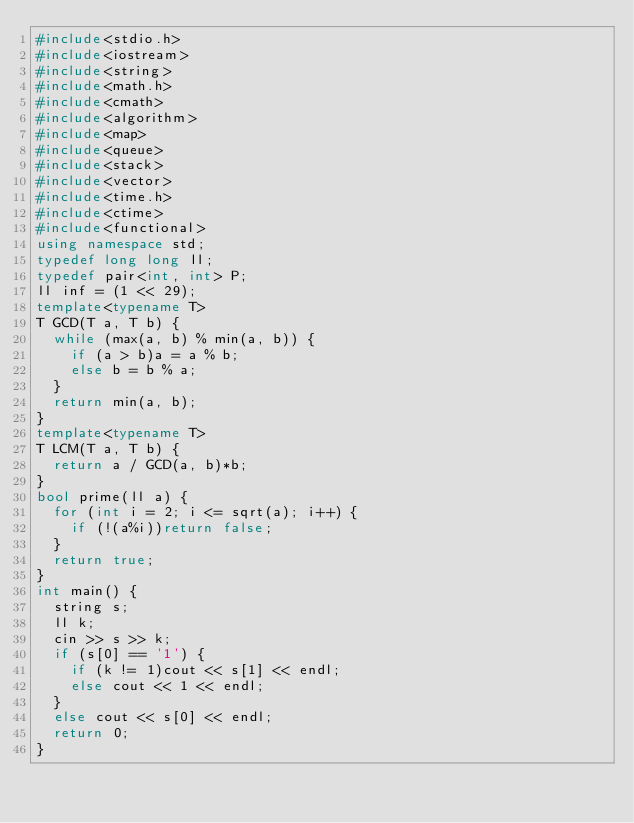<code> <loc_0><loc_0><loc_500><loc_500><_C++_>#include<stdio.h>
#include<iostream>
#include<string>
#include<math.h>
#include<cmath>
#include<algorithm>
#include<map>
#include<queue>
#include<stack>
#include<vector>
#include<time.h>
#include<ctime>
#include<functional>
using namespace std;
typedef long long ll;
typedef pair<int, int> P;
ll inf = (1 << 29);
template<typename T>
T GCD(T a, T b) {
	while (max(a, b) % min(a, b)) {
		if (a > b)a = a % b;
		else b = b % a;
	}
	return min(a, b);
}
template<typename T>
T LCM(T a, T b) {
	return a / GCD(a, b)*b;
}
bool prime(ll a) {
	for (int i = 2; i <= sqrt(a); i++) {
		if (!(a%i))return false;
	}
	return true;
}
int main() {
	string s;
	ll k;
	cin >> s >> k;
	if (s[0] == '1') {
		if (k != 1)cout << s[1] << endl;
		else cout << 1 << endl;
	}
	else cout << s[0] << endl;
	return 0;
}
</code> 